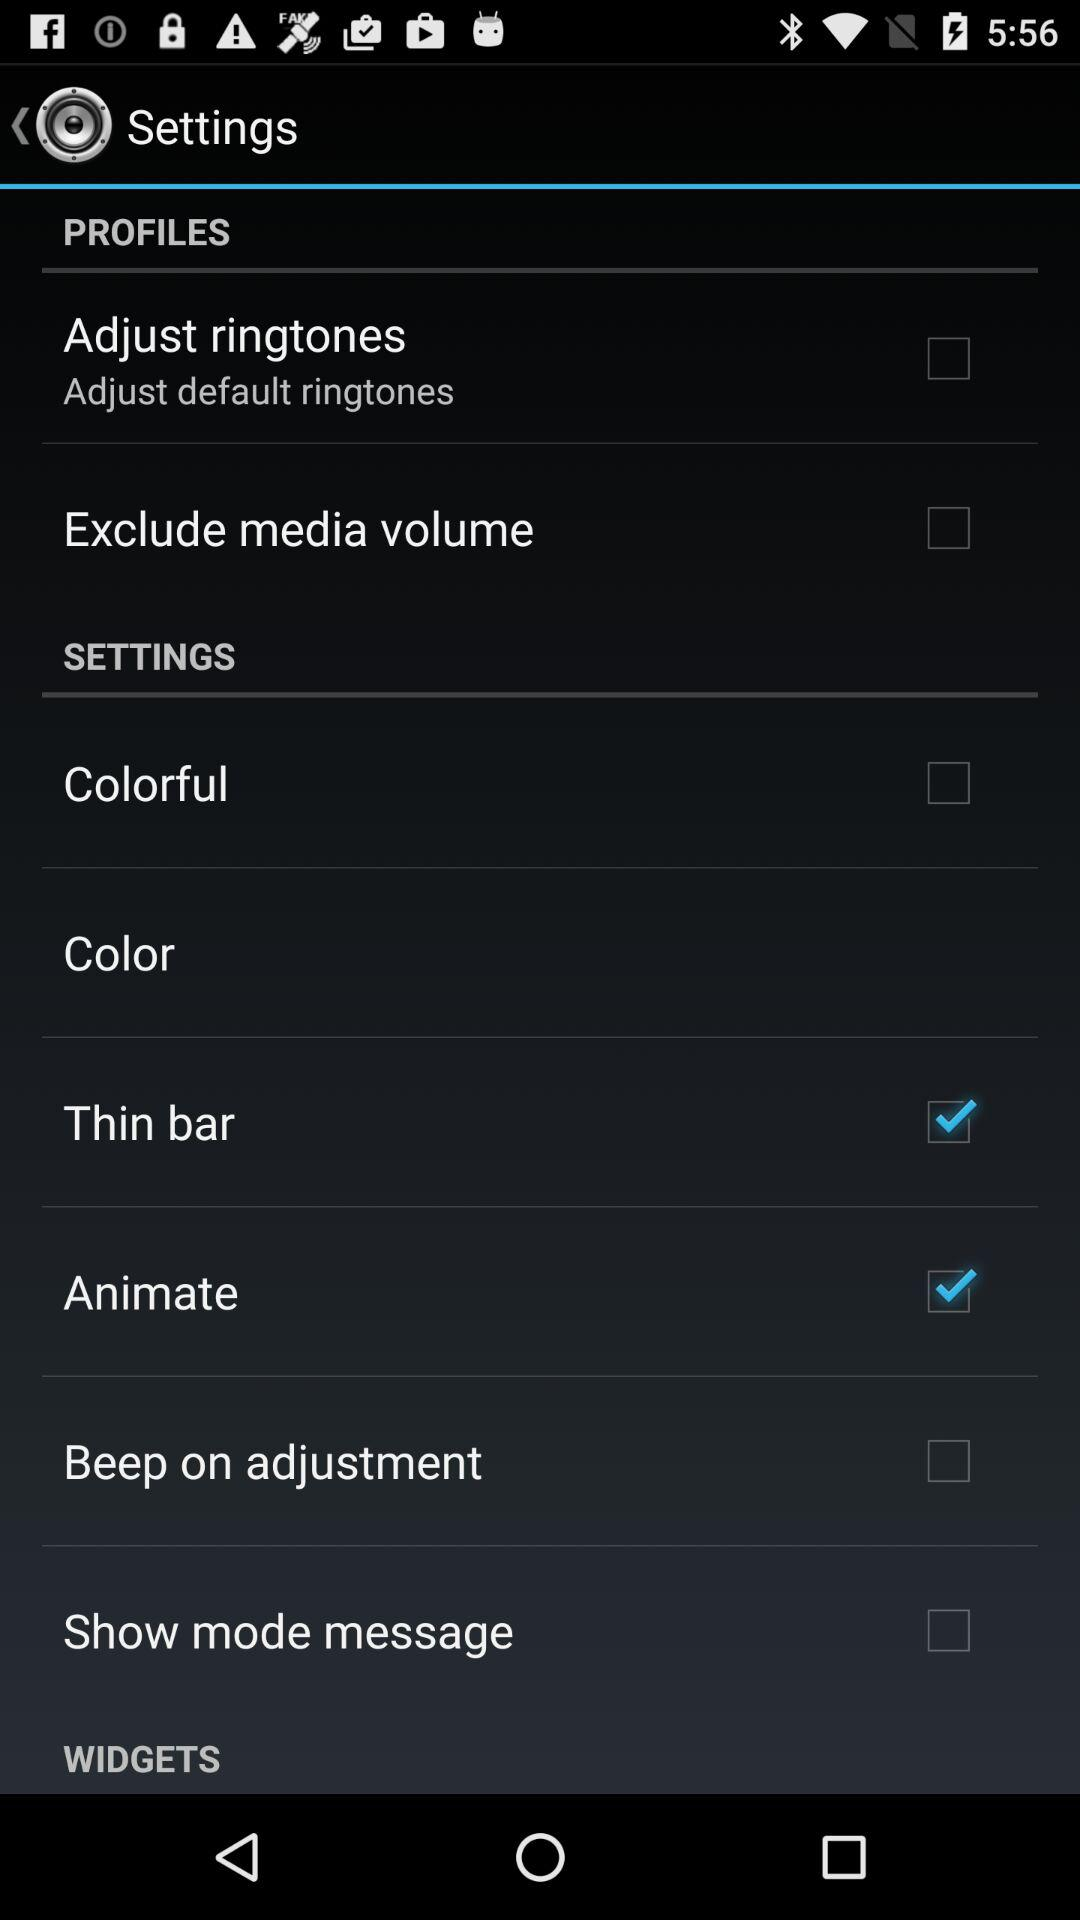What is the status of "Thin bar"? The status is "on". 